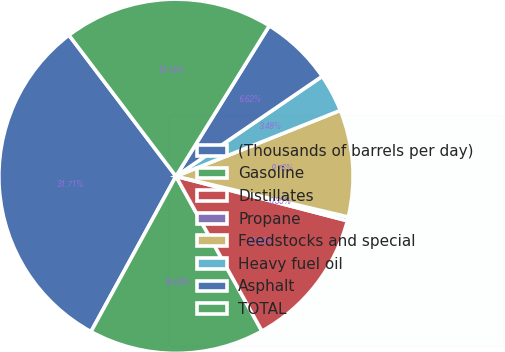Convert chart. <chart><loc_0><loc_0><loc_500><loc_500><pie_chart><fcel>(Thousands of barrels per day)<fcel>Gasoline<fcel>Distillates<fcel>Propane<fcel>Feedstocks and special<fcel>Heavy fuel oil<fcel>Asphalt<fcel>TOTAL<nl><fcel>31.71%<fcel>16.03%<fcel>12.89%<fcel>0.35%<fcel>9.76%<fcel>3.48%<fcel>6.62%<fcel>19.16%<nl></chart> 